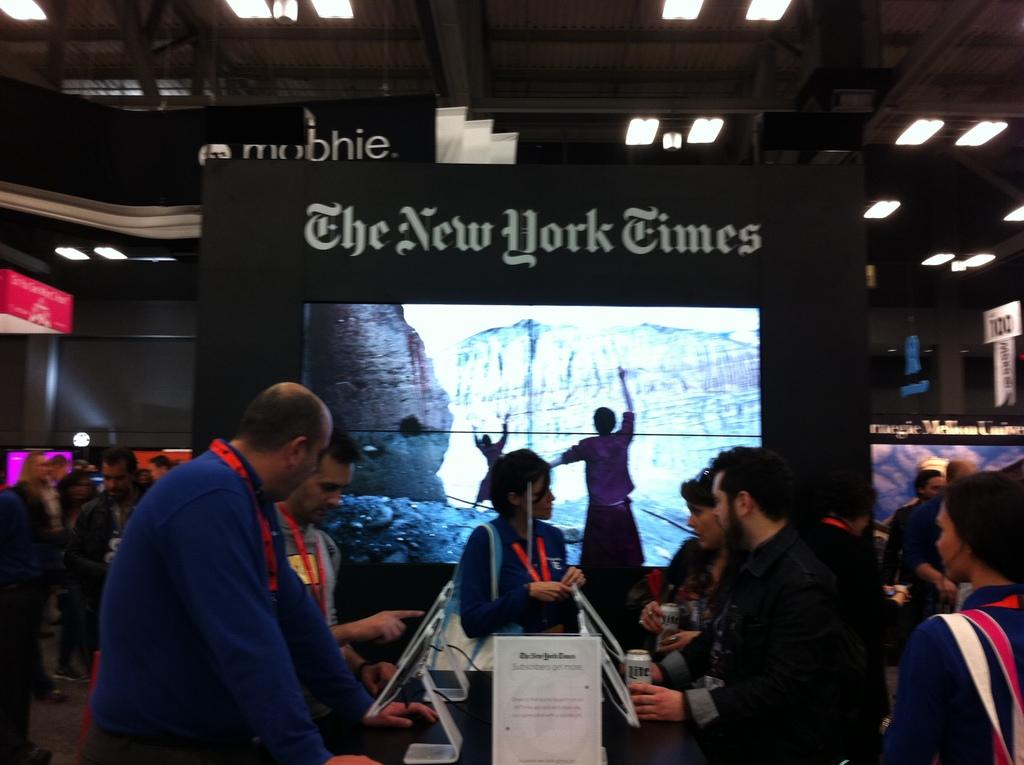What is happening in the foreground of the image? There are people standing in the foreground of the image. What are the people in the foreground doing? The people in the foreground are looking at something. What else can be seen in the image? There are people standing in the background of the image and a screen is present. What type of mountain is depicted on the screen in the image? There is no mountain depicted on the screen in the image. What is the historical significance of the people standing in the background? The provided facts do not mention any historical significance related to the people standing in the background. 